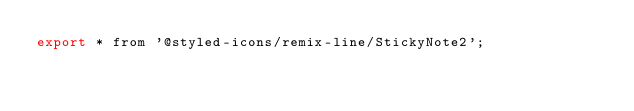Convert code to text. <code><loc_0><loc_0><loc_500><loc_500><_JavaScript_>export * from '@styled-icons/remix-line/StickyNote2';
</code> 